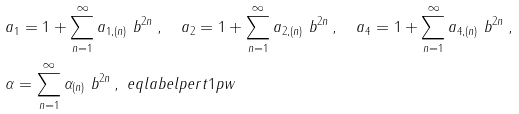<formula> <loc_0><loc_0><loc_500><loc_500>& a _ { 1 } = 1 + \sum _ { n = 1 } ^ { \infty } a _ { 1 , ( n ) } \ b ^ { 2 n } \, , \quad a _ { 2 } = 1 + \sum _ { n = 1 } ^ { \infty } a _ { 2 , ( n ) } \ b ^ { 2 n } \, , \quad a _ { 4 } = 1 + \sum _ { n = 1 } ^ { \infty } a _ { 4 , ( n ) } \ b ^ { 2 n } \, , \\ & \alpha = \sum _ { n = 1 } ^ { \infty } \alpha _ { ( n ) } \ b ^ { 2 n } \, , \ e q l a b e l { p e r t 1 p w }</formula> 